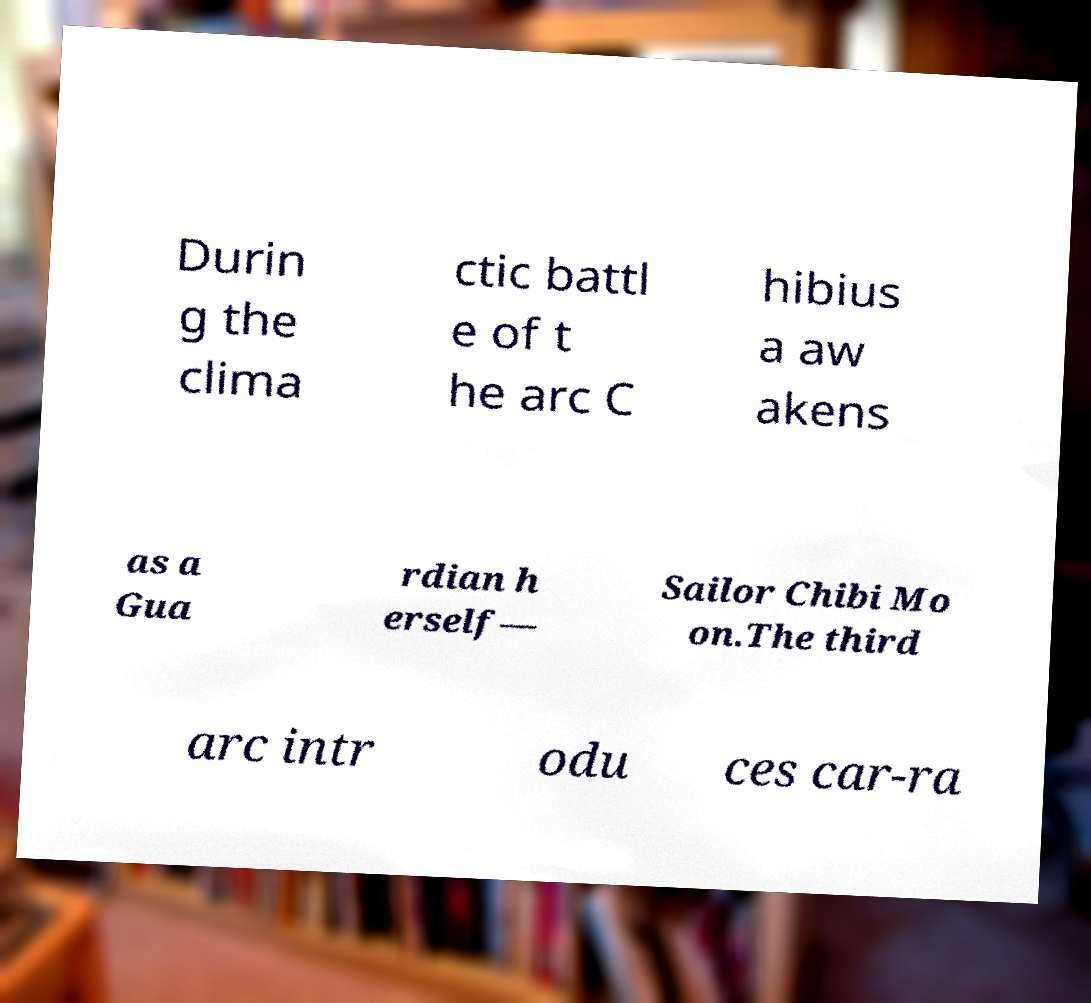Please read and relay the text visible in this image. What does it say? Durin g the clima ctic battl e of t he arc C hibius a aw akens as a Gua rdian h erself— Sailor Chibi Mo on.The third arc intr odu ces car-ra 